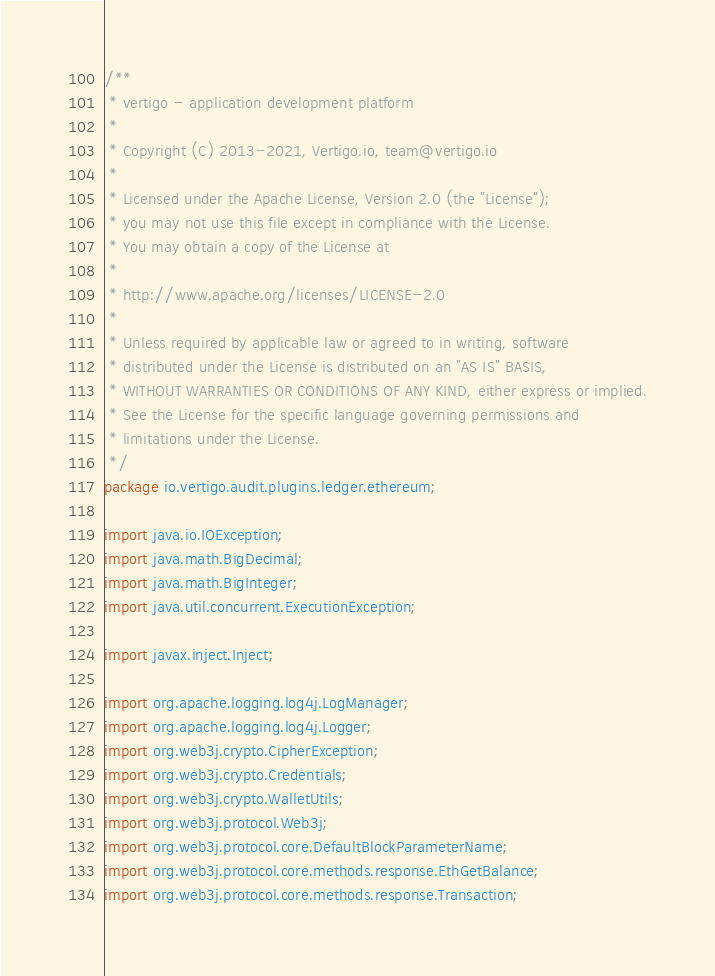Convert code to text. <code><loc_0><loc_0><loc_500><loc_500><_Java_>/**
 * vertigo - application development platform
 *
 * Copyright (C) 2013-2021, Vertigo.io, team@vertigo.io
 *
 * Licensed under the Apache License, Version 2.0 (the "License");
 * you may not use this file except in compliance with the License.
 * You may obtain a copy of the License at
 *
 * http://www.apache.org/licenses/LICENSE-2.0
 *
 * Unless required by applicable law or agreed to in writing, software
 * distributed under the License is distributed on an "AS IS" BASIS,
 * WITHOUT WARRANTIES OR CONDITIONS OF ANY KIND, either express or implied.
 * See the License for the specific language governing permissions and
 * limitations under the License.
 */
package io.vertigo.audit.plugins.ledger.ethereum;

import java.io.IOException;
import java.math.BigDecimal;
import java.math.BigInteger;
import java.util.concurrent.ExecutionException;

import javax.inject.Inject;

import org.apache.logging.log4j.LogManager;
import org.apache.logging.log4j.Logger;
import org.web3j.crypto.CipherException;
import org.web3j.crypto.Credentials;
import org.web3j.crypto.WalletUtils;
import org.web3j.protocol.Web3j;
import org.web3j.protocol.core.DefaultBlockParameterName;
import org.web3j.protocol.core.methods.response.EthGetBalance;
import org.web3j.protocol.core.methods.response.Transaction;</code> 